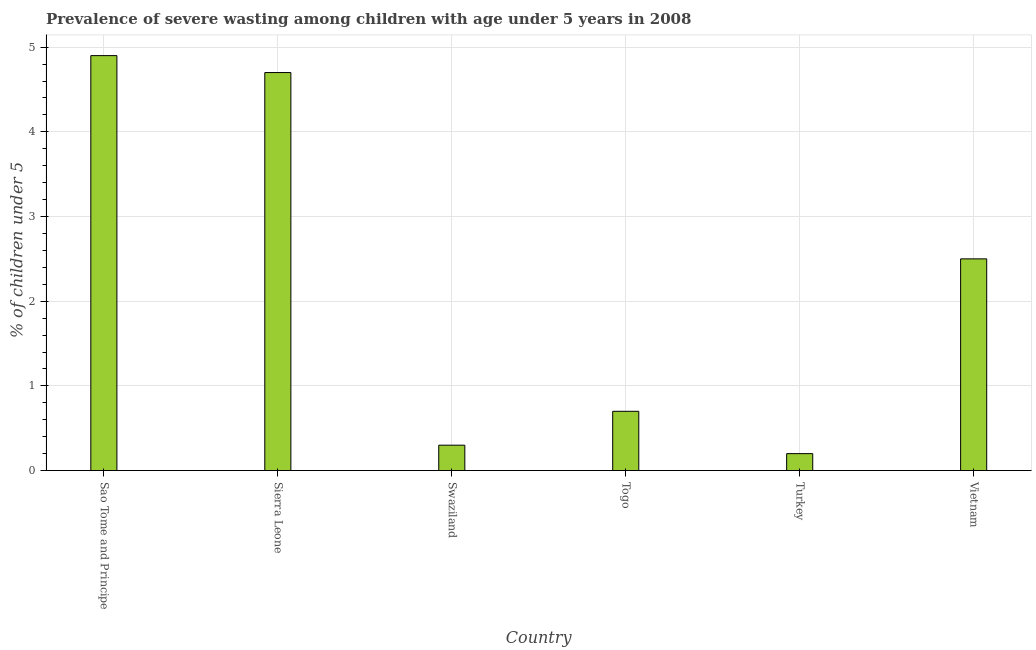What is the title of the graph?
Your answer should be very brief. Prevalence of severe wasting among children with age under 5 years in 2008. What is the label or title of the Y-axis?
Your response must be concise.  % of children under 5. What is the prevalence of severe wasting in Togo?
Provide a short and direct response. 0.7. Across all countries, what is the maximum prevalence of severe wasting?
Your answer should be compact. 4.9. Across all countries, what is the minimum prevalence of severe wasting?
Give a very brief answer. 0.2. In which country was the prevalence of severe wasting maximum?
Provide a succinct answer. Sao Tome and Principe. In which country was the prevalence of severe wasting minimum?
Make the answer very short. Turkey. What is the sum of the prevalence of severe wasting?
Ensure brevity in your answer.  13.3. What is the average prevalence of severe wasting per country?
Your answer should be compact. 2.22. What is the median prevalence of severe wasting?
Ensure brevity in your answer.  1.6. What is the ratio of the prevalence of severe wasting in Sao Tome and Principe to that in Sierra Leone?
Your answer should be compact. 1.04. Is the difference between the prevalence of severe wasting in Sao Tome and Principe and Sierra Leone greater than the difference between any two countries?
Offer a very short reply. No. What is the difference between the highest and the second highest prevalence of severe wasting?
Provide a succinct answer. 0.2. What is the difference between the highest and the lowest prevalence of severe wasting?
Your response must be concise. 4.7. How many bars are there?
Offer a terse response. 6. What is the difference between two consecutive major ticks on the Y-axis?
Give a very brief answer. 1. What is the  % of children under 5 of Sao Tome and Principe?
Your answer should be very brief. 4.9. What is the  % of children under 5 in Sierra Leone?
Keep it short and to the point. 4.7. What is the  % of children under 5 of Swaziland?
Ensure brevity in your answer.  0.3. What is the  % of children under 5 of Togo?
Provide a short and direct response. 0.7. What is the  % of children under 5 of Turkey?
Provide a succinct answer. 0.2. What is the  % of children under 5 in Vietnam?
Offer a very short reply. 2.5. What is the difference between the  % of children under 5 in Sao Tome and Principe and Sierra Leone?
Give a very brief answer. 0.2. What is the difference between the  % of children under 5 in Sao Tome and Principe and Swaziland?
Your answer should be compact. 4.6. What is the difference between the  % of children under 5 in Sao Tome and Principe and Turkey?
Give a very brief answer. 4.7. What is the difference between the  % of children under 5 in Sierra Leone and Togo?
Ensure brevity in your answer.  4. What is the difference between the  % of children under 5 in Swaziland and Vietnam?
Provide a short and direct response. -2.2. What is the difference between the  % of children under 5 in Togo and Turkey?
Your answer should be compact. 0.5. What is the difference between the  % of children under 5 in Togo and Vietnam?
Your answer should be compact. -1.8. What is the difference between the  % of children under 5 in Turkey and Vietnam?
Your response must be concise. -2.3. What is the ratio of the  % of children under 5 in Sao Tome and Principe to that in Sierra Leone?
Provide a short and direct response. 1.04. What is the ratio of the  % of children under 5 in Sao Tome and Principe to that in Swaziland?
Ensure brevity in your answer.  16.33. What is the ratio of the  % of children under 5 in Sao Tome and Principe to that in Togo?
Provide a succinct answer. 7. What is the ratio of the  % of children under 5 in Sao Tome and Principe to that in Turkey?
Make the answer very short. 24.5. What is the ratio of the  % of children under 5 in Sao Tome and Principe to that in Vietnam?
Your answer should be compact. 1.96. What is the ratio of the  % of children under 5 in Sierra Leone to that in Swaziland?
Provide a succinct answer. 15.67. What is the ratio of the  % of children under 5 in Sierra Leone to that in Togo?
Provide a succinct answer. 6.71. What is the ratio of the  % of children under 5 in Sierra Leone to that in Vietnam?
Offer a very short reply. 1.88. What is the ratio of the  % of children under 5 in Swaziland to that in Togo?
Your answer should be very brief. 0.43. What is the ratio of the  % of children under 5 in Swaziland to that in Turkey?
Provide a succinct answer. 1.5. What is the ratio of the  % of children under 5 in Swaziland to that in Vietnam?
Your answer should be compact. 0.12. What is the ratio of the  % of children under 5 in Togo to that in Turkey?
Make the answer very short. 3.5. What is the ratio of the  % of children under 5 in Togo to that in Vietnam?
Keep it short and to the point. 0.28. What is the ratio of the  % of children under 5 in Turkey to that in Vietnam?
Offer a terse response. 0.08. 